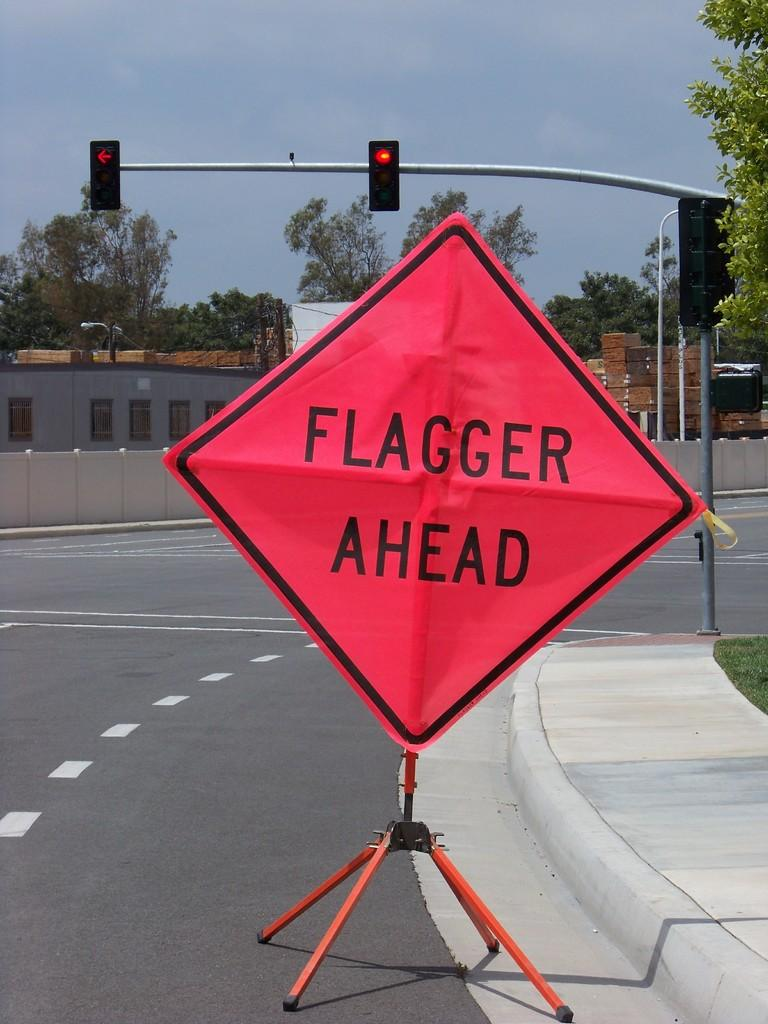<image>
Summarize the visual content of the image. In front of an intersection, a sign is in the right turn lane with the warning that a flagger is ahead. 